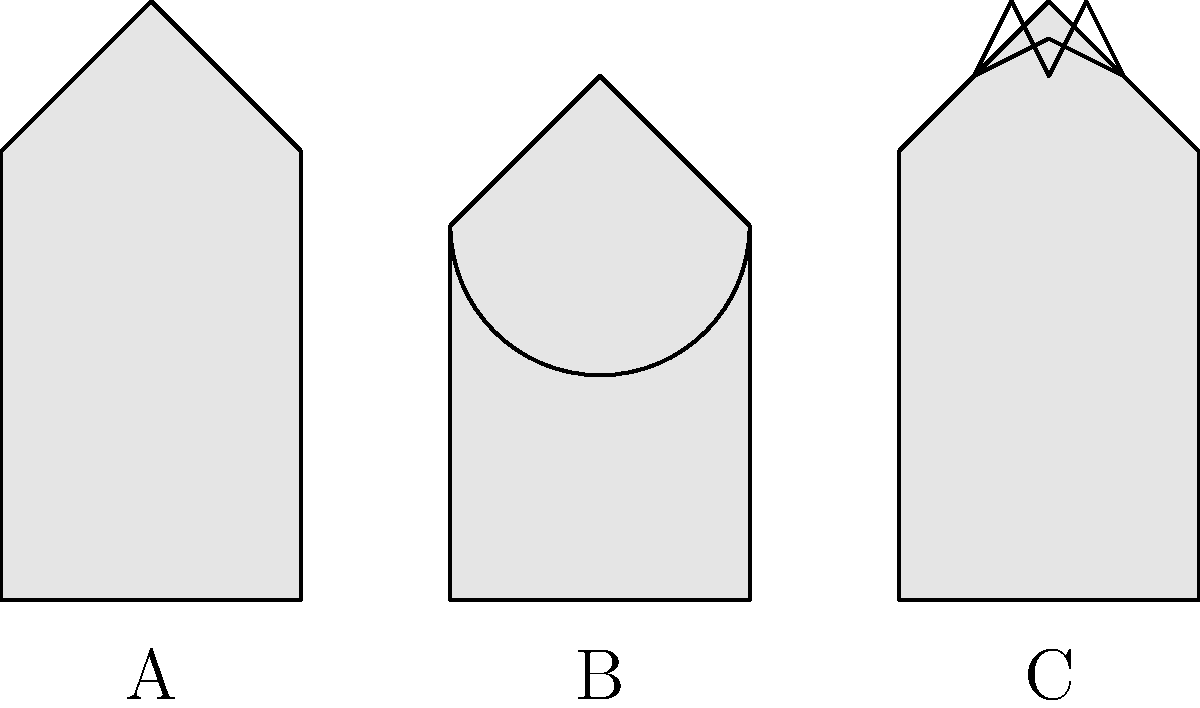As a Christian who appreciates the diversity of religious expressions, can you identify which of the following architectural structures (A, B, or C) most likely represents a mosque? To identify the mosque among these architectural structures, let's examine each one step-by-step:

1. Structure A:
   - Has a simple, rectangular base
   - Features a triangular roof
   - No distinctive religious symbols visible
   This structure could represent a basic church or chapel.

2. Structure B:
   - Has a rectangular base
   - Features a large dome on top
   - The dome is a key characteristic of Islamic architecture
   This structure most closely resembles a typical mosque design.

3. Structure C:
   - Has a rectangular base
   - Features a triangular roof
   - Has a Star of David symbol on top
   This structure likely represents a synagogue, as the Star of David is a symbol of Judaism.

The presence of the dome in Structure B is the most distinctive feature that identifies it as a mosque. Domes are common in Islamic architecture and are often used to create a sense of heavenly space within the mosque.

While as Christians we may be more familiar with church architecture, understanding and appreciating the architectural elements of other faiths can help us foster respect and dialogue between different religious communities, as Jesus taught us to love our neighbors.
Answer: B 